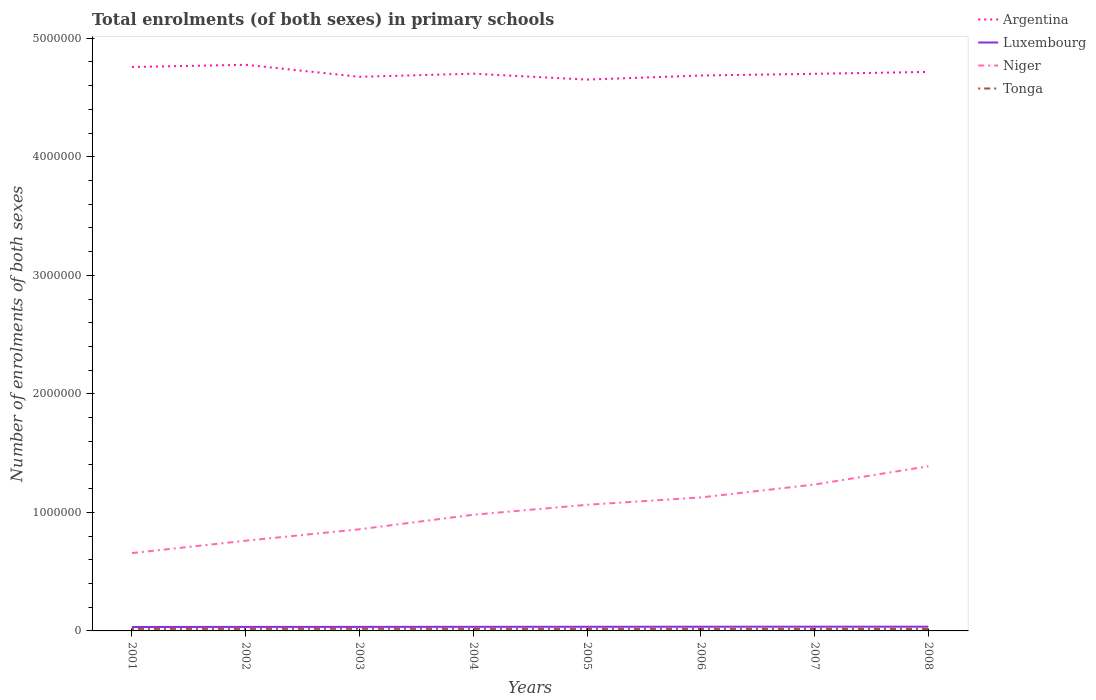How many different coloured lines are there?
Give a very brief answer. 4. Does the line corresponding to Luxembourg intersect with the line corresponding to Tonga?
Offer a terse response. No. Across all years, what is the maximum number of enrolments in primary schools in Argentina?
Your answer should be compact. 4.65e+06. What is the total number of enrolments in primary schools in Tonga in the graph?
Give a very brief answer. 49. What is the difference between the highest and the second highest number of enrolments in primary schools in Luxembourg?
Make the answer very short. 2402. What is the difference between the highest and the lowest number of enrolments in primary schools in Niger?
Ensure brevity in your answer.  4. How many lines are there?
Provide a succinct answer. 4. How many years are there in the graph?
Your answer should be compact. 8. What is the difference between two consecutive major ticks on the Y-axis?
Your answer should be very brief. 1.00e+06. Does the graph contain grids?
Provide a short and direct response. No. Where does the legend appear in the graph?
Provide a short and direct response. Top right. How are the legend labels stacked?
Ensure brevity in your answer.  Vertical. What is the title of the graph?
Offer a terse response. Total enrolments (of both sexes) in primary schools. What is the label or title of the Y-axis?
Provide a succinct answer. Number of enrolments of both sexes. What is the Number of enrolments of both sexes in Argentina in 2001?
Offer a terse response. 4.76e+06. What is the Number of enrolments of both sexes of Luxembourg in 2001?
Your answer should be compact. 3.33e+04. What is the Number of enrolments of both sexes in Niger in 2001?
Provide a short and direct response. 6.57e+05. What is the Number of enrolments of both sexes in Tonga in 2001?
Your answer should be very brief. 1.70e+04. What is the Number of enrolments of both sexes in Argentina in 2002?
Make the answer very short. 4.78e+06. What is the Number of enrolments of both sexes of Luxembourg in 2002?
Give a very brief answer. 3.40e+04. What is the Number of enrolments of both sexes in Niger in 2002?
Your answer should be very brief. 7.61e+05. What is the Number of enrolments of both sexes in Tonga in 2002?
Your answer should be compact. 1.71e+04. What is the Number of enrolments of both sexes in Argentina in 2003?
Your response must be concise. 4.67e+06. What is the Number of enrolments of both sexes of Luxembourg in 2003?
Your answer should be compact. 3.41e+04. What is the Number of enrolments of both sexes in Niger in 2003?
Provide a short and direct response. 8.58e+05. What is the Number of enrolments of both sexes of Tonga in 2003?
Your response must be concise. 1.79e+04. What is the Number of enrolments of both sexes of Argentina in 2004?
Provide a succinct answer. 4.70e+06. What is the Number of enrolments of both sexes in Luxembourg in 2004?
Keep it short and to the point. 3.46e+04. What is the Number of enrolments of both sexes of Niger in 2004?
Make the answer very short. 9.80e+05. What is the Number of enrolments of both sexes in Tonga in 2004?
Make the answer very short. 1.71e+04. What is the Number of enrolments of both sexes of Argentina in 2005?
Offer a terse response. 4.65e+06. What is the Number of enrolments of both sexes of Luxembourg in 2005?
Your answer should be compact. 3.50e+04. What is the Number of enrolments of both sexes of Niger in 2005?
Offer a terse response. 1.06e+06. What is the Number of enrolments of both sexes in Tonga in 2005?
Provide a short and direct response. 1.70e+04. What is the Number of enrolments of both sexes of Argentina in 2006?
Keep it short and to the point. 4.69e+06. What is the Number of enrolments of both sexes in Luxembourg in 2006?
Your answer should be very brief. 3.54e+04. What is the Number of enrolments of both sexes of Niger in 2006?
Offer a terse response. 1.13e+06. What is the Number of enrolments of both sexes in Tonga in 2006?
Your response must be concise. 1.69e+04. What is the Number of enrolments of both sexes of Argentina in 2007?
Offer a very short reply. 4.70e+06. What is the Number of enrolments of both sexes in Luxembourg in 2007?
Your answer should be compact. 3.57e+04. What is the Number of enrolments of both sexes of Niger in 2007?
Keep it short and to the point. 1.24e+06. What is the Number of enrolments of both sexes of Tonga in 2007?
Offer a very short reply. 1.69e+04. What is the Number of enrolments of both sexes in Argentina in 2008?
Make the answer very short. 4.72e+06. What is the Number of enrolments of both sexes in Luxembourg in 2008?
Your response must be concise. 3.56e+04. What is the Number of enrolments of both sexes in Niger in 2008?
Make the answer very short. 1.39e+06. What is the Number of enrolments of both sexes in Tonga in 2008?
Your answer should be very brief. 1.67e+04. Across all years, what is the maximum Number of enrolments of both sexes of Argentina?
Offer a very short reply. 4.78e+06. Across all years, what is the maximum Number of enrolments of both sexes in Luxembourg?
Ensure brevity in your answer.  3.57e+04. Across all years, what is the maximum Number of enrolments of both sexes in Niger?
Your answer should be very brief. 1.39e+06. Across all years, what is the maximum Number of enrolments of both sexes in Tonga?
Make the answer very short. 1.79e+04. Across all years, what is the minimum Number of enrolments of both sexes of Argentina?
Your response must be concise. 4.65e+06. Across all years, what is the minimum Number of enrolments of both sexes of Luxembourg?
Your answer should be compact. 3.33e+04. Across all years, what is the minimum Number of enrolments of both sexes in Niger?
Your answer should be compact. 6.57e+05. Across all years, what is the minimum Number of enrolments of both sexes of Tonga?
Provide a succinct answer. 1.67e+04. What is the total Number of enrolments of both sexes of Argentina in the graph?
Offer a very short reply. 3.77e+07. What is the total Number of enrolments of both sexes of Luxembourg in the graph?
Ensure brevity in your answer.  2.78e+05. What is the total Number of enrolments of both sexes in Niger in the graph?
Keep it short and to the point. 8.07e+06. What is the total Number of enrolments of both sexes in Tonga in the graph?
Your answer should be very brief. 1.37e+05. What is the difference between the Number of enrolments of both sexes in Argentina in 2001 and that in 2002?
Your answer should be compact. -1.86e+04. What is the difference between the Number of enrolments of both sexes in Luxembourg in 2001 and that in 2002?
Offer a terse response. -700. What is the difference between the Number of enrolments of both sexes of Niger in 2001 and that in 2002?
Provide a succinct answer. -1.04e+05. What is the difference between the Number of enrolments of both sexes of Tonga in 2001 and that in 2002?
Provide a succinct answer. -72. What is the difference between the Number of enrolments of both sexes of Argentina in 2001 and that in 2003?
Offer a very short reply. 8.28e+04. What is the difference between the Number of enrolments of both sexes of Luxembourg in 2001 and that in 2003?
Ensure brevity in your answer.  -815. What is the difference between the Number of enrolments of both sexes of Niger in 2001 and that in 2003?
Your answer should be very brief. -2.01e+05. What is the difference between the Number of enrolments of both sexes in Tonga in 2001 and that in 2003?
Provide a succinct answer. -858. What is the difference between the Number of enrolments of both sexes in Argentina in 2001 and that in 2004?
Ensure brevity in your answer.  5.65e+04. What is the difference between the Number of enrolments of both sexes of Luxembourg in 2001 and that in 2004?
Provide a short and direct response. -1337. What is the difference between the Number of enrolments of both sexes in Niger in 2001 and that in 2004?
Provide a succinct answer. -3.23e+05. What is the difference between the Number of enrolments of both sexes of Tonga in 2001 and that in 2004?
Make the answer very short. -80. What is the difference between the Number of enrolments of both sexes of Argentina in 2001 and that in 2005?
Provide a short and direct response. 1.06e+05. What is the difference between the Number of enrolments of both sexes of Luxembourg in 2001 and that in 2005?
Provide a succinct answer. -1750. What is the difference between the Number of enrolments of both sexes of Niger in 2001 and that in 2005?
Your answer should be very brief. -4.07e+05. What is the difference between the Number of enrolments of both sexes in Argentina in 2001 and that in 2006?
Keep it short and to the point. 7.20e+04. What is the difference between the Number of enrolments of both sexes of Luxembourg in 2001 and that in 2006?
Give a very brief answer. -2165. What is the difference between the Number of enrolments of both sexes in Niger in 2001 and that in 2006?
Your response must be concise. -4.69e+05. What is the difference between the Number of enrolments of both sexes of Tonga in 2001 and that in 2006?
Ensure brevity in your answer.  92. What is the difference between the Number of enrolments of both sexes in Argentina in 2001 and that in 2007?
Your answer should be compact. 5.75e+04. What is the difference between the Number of enrolments of both sexes in Luxembourg in 2001 and that in 2007?
Keep it short and to the point. -2402. What is the difference between the Number of enrolments of both sexes of Niger in 2001 and that in 2007?
Provide a succinct answer. -5.78e+05. What is the difference between the Number of enrolments of both sexes of Tonga in 2001 and that in 2007?
Ensure brevity in your answer.  141. What is the difference between the Number of enrolments of both sexes in Argentina in 2001 and that in 2008?
Provide a short and direct response. 4.16e+04. What is the difference between the Number of enrolments of both sexes in Luxembourg in 2001 and that in 2008?
Offer a terse response. -2364. What is the difference between the Number of enrolments of both sexes of Niger in 2001 and that in 2008?
Your response must be concise. -7.33e+05. What is the difference between the Number of enrolments of both sexes of Tonga in 2001 and that in 2008?
Offer a very short reply. 366. What is the difference between the Number of enrolments of both sexes in Argentina in 2002 and that in 2003?
Ensure brevity in your answer.  1.01e+05. What is the difference between the Number of enrolments of both sexes of Luxembourg in 2002 and that in 2003?
Provide a short and direct response. -115. What is the difference between the Number of enrolments of both sexes of Niger in 2002 and that in 2003?
Your answer should be compact. -9.66e+04. What is the difference between the Number of enrolments of both sexes of Tonga in 2002 and that in 2003?
Ensure brevity in your answer.  -786. What is the difference between the Number of enrolments of both sexes in Argentina in 2002 and that in 2004?
Keep it short and to the point. 7.52e+04. What is the difference between the Number of enrolments of both sexes of Luxembourg in 2002 and that in 2004?
Your answer should be very brief. -637. What is the difference between the Number of enrolments of both sexes in Niger in 2002 and that in 2004?
Make the answer very short. -2.19e+05. What is the difference between the Number of enrolments of both sexes of Tonga in 2002 and that in 2004?
Ensure brevity in your answer.  -8. What is the difference between the Number of enrolments of both sexes of Argentina in 2002 and that in 2005?
Your response must be concise. 1.25e+05. What is the difference between the Number of enrolments of both sexes of Luxembourg in 2002 and that in 2005?
Offer a very short reply. -1050. What is the difference between the Number of enrolments of both sexes in Niger in 2002 and that in 2005?
Provide a short and direct response. -3.03e+05. What is the difference between the Number of enrolments of both sexes in Argentina in 2002 and that in 2006?
Your answer should be compact. 9.06e+04. What is the difference between the Number of enrolments of both sexes in Luxembourg in 2002 and that in 2006?
Your answer should be very brief. -1465. What is the difference between the Number of enrolments of both sexes in Niger in 2002 and that in 2006?
Give a very brief answer. -3.65e+05. What is the difference between the Number of enrolments of both sexes of Tonga in 2002 and that in 2006?
Your answer should be compact. 164. What is the difference between the Number of enrolments of both sexes of Argentina in 2002 and that in 2007?
Provide a short and direct response. 7.61e+04. What is the difference between the Number of enrolments of both sexes in Luxembourg in 2002 and that in 2007?
Your response must be concise. -1702. What is the difference between the Number of enrolments of both sexes of Niger in 2002 and that in 2007?
Provide a short and direct response. -4.74e+05. What is the difference between the Number of enrolments of both sexes of Tonga in 2002 and that in 2007?
Ensure brevity in your answer.  213. What is the difference between the Number of enrolments of both sexes of Argentina in 2002 and that in 2008?
Your response must be concise. 6.02e+04. What is the difference between the Number of enrolments of both sexes of Luxembourg in 2002 and that in 2008?
Your response must be concise. -1664. What is the difference between the Number of enrolments of both sexes in Niger in 2002 and that in 2008?
Provide a succinct answer. -6.28e+05. What is the difference between the Number of enrolments of both sexes of Tonga in 2002 and that in 2008?
Provide a succinct answer. 438. What is the difference between the Number of enrolments of both sexes in Argentina in 2003 and that in 2004?
Make the answer very short. -2.63e+04. What is the difference between the Number of enrolments of both sexes of Luxembourg in 2003 and that in 2004?
Make the answer very short. -522. What is the difference between the Number of enrolments of both sexes of Niger in 2003 and that in 2004?
Your response must be concise. -1.22e+05. What is the difference between the Number of enrolments of both sexes in Tonga in 2003 and that in 2004?
Provide a short and direct response. 778. What is the difference between the Number of enrolments of both sexes in Argentina in 2003 and that in 2005?
Your response must be concise. 2.36e+04. What is the difference between the Number of enrolments of both sexes in Luxembourg in 2003 and that in 2005?
Offer a very short reply. -935. What is the difference between the Number of enrolments of both sexes of Niger in 2003 and that in 2005?
Your answer should be compact. -2.06e+05. What is the difference between the Number of enrolments of both sexes in Tonga in 2003 and that in 2005?
Your answer should be compact. 859. What is the difference between the Number of enrolments of both sexes of Argentina in 2003 and that in 2006?
Keep it short and to the point. -1.08e+04. What is the difference between the Number of enrolments of both sexes of Luxembourg in 2003 and that in 2006?
Offer a terse response. -1350. What is the difference between the Number of enrolments of both sexes in Niger in 2003 and that in 2006?
Offer a terse response. -2.68e+05. What is the difference between the Number of enrolments of both sexes of Tonga in 2003 and that in 2006?
Offer a terse response. 950. What is the difference between the Number of enrolments of both sexes of Argentina in 2003 and that in 2007?
Offer a very short reply. -2.53e+04. What is the difference between the Number of enrolments of both sexes of Luxembourg in 2003 and that in 2007?
Make the answer very short. -1587. What is the difference between the Number of enrolments of both sexes of Niger in 2003 and that in 2007?
Your answer should be compact. -3.77e+05. What is the difference between the Number of enrolments of both sexes in Tonga in 2003 and that in 2007?
Offer a terse response. 999. What is the difference between the Number of enrolments of both sexes of Argentina in 2003 and that in 2008?
Your response must be concise. -4.12e+04. What is the difference between the Number of enrolments of both sexes in Luxembourg in 2003 and that in 2008?
Offer a very short reply. -1549. What is the difference between the Number of enrolments of both sexes of Niger in 2003 and that in 2008?
Provide a succinct answer. -5.32e+05. What is the difference between the Number of enrolments of both sexes of Tonga in 2003 and that in 2008?
Your response must be concise. 1224. What is the difference between the Number of enrolments of both sexes in Argentina in 2004 and that in 2005?
Give a very brief answer. 4.99e+04. What is the difference between the Number of enrolments of both sexes of Luxembourg in 2004 and that in 2005?
Ensure brevity in your answer.  -413. What is the difference between the Number of enrolments of both sexes in Niger in 2004 and that in 2005?
Give a very brief answer. -8.40e+04. What is the difference between the Number of enrolments of both sexes of Tonga in 2004 and that in 2005?
Offer a very short reply. 81. What is the difference between the Number of enrolments of both sexes of Argentina in 2004 and that in 2006?
Make the answer very short. 1.55e+04. What is the difference between the Number of enrolments of both sexes in Luxembourg in 2004 and that in 2006?
Offer a terse response. -828. What is the difference between the Number of enrolments of both sexes of Niger in 2004 and that in 2006?
Provide a succinct answer. -1.46e+05. What is the difference between the Number of enrolments of both sexes in Tonga in 2004 and that in 2006?
Make the answer very short. 172. What is the difference between the Number of enrolments of both sexes in Argentina in 2004 and that in 2007?
Ensure brevity in your answer.  973. What is the difference between the Number of enrolments of both sexes in Luxembourg in 2004 and that in 2007?
Provide a succinct answer. -1065. What is the difference between the Number of enrolments of both sexes of Niger in 2004 and that in 2007?
Ensure brevity in your answer.  -2.55e+05. What is the difference between the Number of enrolments of both sexes of Tonga in 2004 and that in 2007?
Provide a succinct answer. 221. What is the difference between the Number of enrolments of both sexes in Argentina in 2004 and that in 2008?
Your answer should be very brief. -1.50e+04. What is the difference between the Number of enrolments of both sexes of Luxembourg in 2004 and that in 2008?
Give a very brief answer. -1027. What is the difference between the Number of enrolments of both sexes in Niger in 2004 and that in 2008?
Your answer should be compact. -4.09e+05. What is the difference between the Number of enrolments of both sexes of Tonga in 2004 and that in 2008?
Make the answer very short. 446. What is the difference between the Number of enrolments of both sexes of Argentina in 2005 and that in 2006?
Ensure brevity in your answer.  -3.44e+04. What is the difference between the Number of enrolments of both sexes in Luxembourg in 2005 and that in 2006?
Make the answer very short. -415. What is the difference between the Number of enrolments of both sexes in Niger in 2005 and that in 2006?
Provide a short and direct response. -6.20e+04. What is the difference between the Number of enrolments of both sexes of Tonga in 2005 and that in 2006?
Provide a succinct answer. 91. What is the difference between the Number of enrolments of both sexes of Argentina in 2005 and that in 2007?
Offer a terse response. -4.89e+04. What is the difference between the Number of enrolments of both sexes in Luxembourg in 2005 and that in 2007?
Your response must be concise. -652. What is the difference between the Number of enrolments of both sexes of Niger in 2005 and that in 2007?
Ensure brevity in your answer.  -1.71e+05. What is the difference between the Number of enrolments of both sexes in Tonga in 2005 and that in 2007?
Your response must be concise. 140. What is the difference between the Number of enrolments of both sexes in Argentina in 2005 and that in 2008?
Give a very brief answer. -6.48e+04. What is the difference between the Number of enrolments of both sexes in Luxembourg in 2005 and that in 2008?
Offer a terse response. -614. What is the difference between the Number of enrolments of both sexes in Niger in 2005 and that in 2008?
Offer a very short reply. -3.25e+05. What is the difference between the Number of enrolments of both sexes in Tonga in 2005 and that in 2008?
Make the answer very short. 365. What is the difference between the Number of enrolments of both sexes in Argentina in 2006 and that in 2007?
Your answer should be very brief. -1.45e+04. What is the difference between the Number of enrolments of both sexes of Luxembourg in 2006 and that in 2007?
Make the answer very short. -237. What is the difference between the Number of enrolments of both sexes of Niger in 2006 and that in 2007?
Ensure brevity in your answer.  -1.09e+05. What is the difference between the Number of enrolments of both sexes in Argentina in 2006 and that in 2008?
Give a very brief answer. -3.04e+04. What is the difference between the Number of enrolments of both sexes in Luxembourg in 2006 and that in 2008?
Your answer should be very brief. -199. What is the difference between the Number of enrolments of both sexes of Niger in 2006 and that in 2008?
Keep it short and to the point. -2.63e+05. What is the difference between the Number of enrolments of both sexes in Tonga in 2006 and that in 2008?
Provide a short and direct response. 274. What is the difference between the Number of enrolments of both sexes of Argentina in 2007 and that in 2008?
Provide a succinct answer. -1.59e+04. What is the difference between the Number of enrolments of both sexes of Niger in 2007 and that in 2008?
Ensure brevity in your answer.  -1.54e+05. What is the difference between the Number of enrolments of both sexes in Tonga in 2007 and that in 2008?
Keep it short and to the point. 225. What is the difference between the Number of enrolments of both sexes of Argentina in 2001 and the Number of enrolments of both sexes of Luxembourg in 2002?
Ensure brevity in your answer.  4.72e+06. What is the difference between the Number of enrolments of both sexes in Argentina in 2001 and the Number of enrolments of both sexes in Niger in 2002?
Offer a very short reply. 4.00e+06. What is the difference between the Number of enrolments of both sexes in Argentina in 2001 and the Number of enrolments of both sexes in Tonga in 2002?
Provide a short and direct response. 4.74e+06. What is the difference between the Number of enrolments of both sexes of Luxembourg in 2001 and the Number of enrolments of both sexes of Niger in 2002?
Provide a short and direct response. -7.28e+05. What is the difference between the Number of enrolments of both sexes in Luxembourg in 2001 and the Number of enrolments of both sexes in Tonga in 2002?
Provide a short and direct response. 1.62e+04. What is the difference between the Number of enrolments of both sexes of Niger in 2001 and the Number of enrolments of both sexes of Tonga in 2002?
Ensure brevity in your answer.  6.39e+05. What is the difference between the Number of enrolments of both sexes of Argentina in 2001 and the Number of enrolments of both sexes of Luxembourg in 2003?
Ensure brevity in your answer.  4.72e+06. What is the difference between the Number of enrolments of both sexes of Argentina in 2001 and the Number of enrolments of both sexes of Niger in 2003?
Provide a short and direct response. 3.90e+06. What is the difference between the Number of enrolments of both sexes of Argentina in 2001 and the Number of enrolments of both sexes of Tonga in 2003?
Keep it short and to the point. 4.74e+06. What is the difference between the Number of enrolments of both sexes in Luxembourg in 2001 and the Number of enrolments of both sexes in Niger in 2003?
Make the answer very short. -8.24e+05. What is the difference between the Number of enrolments of both sexes in Luxembourg in 2001 and the Number of enrolments of both sexes in Tonga in 2003?
Ensure brevity in your answer.  1.54e+04. What is the difference between the Number of enrolments of both sexes of Niger in 2001 and the Number of enrolments of both sexes of Tonga in 2003?
Provide a short and direct response. 6.39e+05. What is the difference between the Number of enrolments of both sexes in Argentina in 2001 and the Number of enrolments of both sexes in Luxembourg in 2004?
Ensure brevity in your answer.  4.72e+06. What is the difference between the Number of enrolments of both sexes of Argentina in 2001 and the Number of enrolments of both sexes of Niger in 2004?
Keep it short and to the point. 3.78e+06. What is the difference between the Number of enrolments of both sexes of Argentina in 2001 and the Number of enrolments of both sexes of Tonga in 2004?
Your answer should be very brief. 4.74e+06. What is the difference between the Number of enrolments of both sexes in Luxembourg in 2001 and the Number of enrolments of both sexes in Niger in 2004?
Your answer should be compact. -9.47e+05. What is the difference between the Number of enrolments of both sexes in Luxembourg in 2001 and the Number of enrolments of both sexes in Tonga in 2004?
Give a very brief answer. 1.62e+04. What is the difference between the Number of enrolments of both sexes in Niger in 2001 and the Number of enrolments of both sexes in Tonga in 2004?
Offer a terse response. 6.39e+05. What is the difference between the Number of enrolments of both sexes of Argentina in 2001 and the Number of enrolments of both sexes of Luxembourg in 2005?
Keep it short and to the point. 4.72e+06. What is the difference between the Number of enrolments of both sexes in Argentina in 2001 and the Number of enrolments of both sexes in Niger in 2005?
Keep it short and to the point. 3.69e+06. What is the difference between the Number of enrolments of both sexes of Argentina in 2001 and the Number of enrolments of both sexes of Tonga in 2005?
Offer a terse response. 4.74e+06. What is the difference between the Number of enrolments of both sexes in Luxembourg in 2001 and the Number of enrolments of both sexes in Niger in 2005?
Give a very brief answer. -1.03e+06. What is the difference between the Number of enrolments of both sexes of Luxembourg in 2001 and the Number of enrolments of both sexes of Tonga in 2005?
Make the answer very short. 1.62e+04. What is the difference between the Number of enrolments of both sexes in Niger in 2001 and the Number of enrolments of both sexes in Tonga in 2005?
Offer a terse response. 6.40e+05. What is the difference between the Number of enrolments of both sexes in Argentina in 2001 and the Number of enrolments of both sexes in Luxembourg in 2006?
Provide a succinct answer. 4.72e+06. What is the difference between the Number of enrolments of both sexes in Argentina in 2001 and the Number of enrolments of both sexes in Niger in 2006?
Make the answer very short. 3.63e+06. What is the difference between the Number of enrolments of both sexes in Argentina in 2001 and the Number of enrolments of both sexes in Tonga in 2006?
Offer a terse response. 4.74e+06. What is the difference between the Number of enrolments of both sexes of Luxembourg in 2001 and the Number of enrolments of both sexes of Niger in 2006?
Your answer should be very brief. -1.09e+06. What is the difference between the Number of enrolments of both sexes in Luxembourg in 2001 and the Number of enrolments of both sexes in Tonga in 2006?
Your answer should be very brief. 1.63e+04. What is the difference between the Number of enrolments of both sexes in Niger in 2001 and the Number of enrolments of both sexes in Tonga in 2006?
Give a very brief answer. 6.40e+05. What is the difference between the Number of enrolments of both sexes in Argentina in 2001 and the Number of enrolments of both sexes in Luxembourg in 2007?
Make the answer very short. 4.72e+06. What is the difference between the Number of enrolments of both sexes of Argentina in 2001 and the Number of enrolments of both sexes of Niger in 2007?
Ensure brevity in your answer.  3.52e+06. What is the difference between the Number of enrolments of both sexes of Argentina in 2001 and the Number of enrolments of both sexes of Tonga in 2007?
Make the answer very short. 4.74e+06. What is the difference between the Number of enrolments of both sexes of Luxembourg in 2001 and the Number of enrolments of both sexes of Niger in 2007?
Provide a short and direct response. -1.20e+06. What is the difference between the Number of enrolments of both sexes in Luxembourg in 2001 and the Number of enrolments of both sexes in Tonga in 2007?
Your answer should be compact. 1.64e+04. What is the difference between the Number of enrolments of both sexes in Niger in 2001 and the Number of enrolments of both sexes in Tonga in 2007?
Your answer should be compact. 6.40e+05. What is the difference between the Number of enrolments of both sexes in Argentina in 2001 and the Number of enrolments of both sexes in Luxembourg in 2008?
Offer a terse response. 4.72e+06. What is the difference between the Number of enrolments of both sexes of Argentina in 2001 and the Number of enrolments of both sexes of Niger in 2008?
Your answer should be compact. 3.37e+06. What is the difference between the Number of enrolments of both sexes of Argentina in 2001 and the Number of enrolments of both sexes of Tonga in 2008?
Keep it short and to the point. 4.74e+06. What is the difference between the Number of enrolments of both sexes in Luxembourg in 2001 and the Number of enrolments of both sexes in Niger in 2008?
Your answer should be very brief. -1.36e+06. What is the difference between the Number of enrolments of both sexes in Luxembourg in 2001 and the Number of enrolments of both sexes in Tonga in 2008?
Offer a terse response. 1.66e+04. What is the difference between the Number of enrolments of both sexes in Niger in 2001 and the Number of enrolments of both sexes in Tonga in 2008?
Your answer should be very brief. 6.40e+05. What is the difference between the Number of enrolments of both sexes in Argentina in 2002 and the Number of enrolments of both sexes in Luxembourg in 2003?
Your response must be concise. 4.74e+06. What is the difference between the Number of enrolments of both sexes of Argentina in 2002 and the Number of enrolments of both sexes of Niger in 2003?
Your answer should be very brief. 3.92e+06. What is the difference between the Number of enrolments of both sexes of Argentina in 2002 and the Number of enrolments of both sexes of Tonga in 2003?
Offer a terse response. 4.76e+06. What is the difference between the Number of enrolments of both sexes in Luxembourg in 2002 and the Number of enrolments of both sexes in Niger in 2003?
Your answer should be compact. -8.24e+05. What is the difference between the Number of enrolments of both sexes of Luxembourg in 2002 and the Number of enrolments of both sexes of Tonga in 2003?
Keep it short and to the point. 1.61e+04. What is the difference between the Number of enrolments of both sexes in Niger in 2002 and the Number of enrolments of both sexes in Tonga in 2003?
Your answer should be very brief. 7.43e+05. What is the difference between the Number of enrolments of both sexes of Argentina in 2002 and the Number of enrolments of both sexes of Luxembourg in 2004?
Offer a very short reply. 4.74e+06. What is the difference between the Number of enrolments of both sexes in Argentina in 2002 and the Number of enrolments of both sexes in Niger in 2004?
Provide a short and direct response. 3.80e+06. What is the difference between the Number of enrolments of both sexes in Argentina in 2002 and the Number of enrolments of both sexes in Tonga in 2004?
Keep it short and to the point. 4.76e+06. What is the difference between the Number of enrolments of both sexes in Luxembourg in 2002 and the Number of enrolments of both sexes in Niger in 2004?
Provide a succinct answer. -9.46e+05. What is the difference between the Number of enrolments of both sexes in Luxembourg in 2002 and the Number of enrolments of both sexes in Tonga in 2004?
Ensure brevity in your answer.  1.69e+04. What is the difference between the Number of enrolments of both sexes of Niger in 2002 and the Number of enrolments of both sexes of Tonga in 2004?
Keep it short and to the point. 7.44e+05. What is the difference between the Number of enrolments of both sexes of Argentina in 2002 and the Number of enrolments of both sexes of Luxembourg in 2005?
Give a very brief answer. 4.74e+06. What is the difference between the Number of enrolments of both sexes of Argentina in 2002 and the Number of enrolments of both sexes of Niger in 2005?
Give a very brief answer. 3.71e+06. What is the difference between the Number of enrolments of both sexes in Argentina in 2002 and the Number of enrolments of both sexes in Tonga in 2005?
Offer a terse response. 4.76e+06. What is the difference between the Number of enrolments of both sexes in Luxembourg in 2002 and the Number of enrolments of both sexes in Niger in 2005?
Offer a terse response. -1.03e+06. What is the difference between the Number of enrolments of both sexes of Luxembourg in 2002 and the Number of enrolments of both sexes of Tonga in 2005?
Your answer should be very brief. 1.69e+04. What is the difference between the Number of enrolments of both sexes in Niger in 2002 and the Number of enrolments of both sexes in Tonga in 2005?
Keep it short and to the point. 7.44e+05. What is the difference between the Number of enrolments of both sexes of Argentina in 2002 and the Number of enrolments of both sexes of Luxembourg in 2006?
Keep it short and to the point. 4.74e+06. What is the difference between the Number of enrolments of both sexes in Argentina in 2002 and the Number of enrolments of both sexes in Niger in 2006?
Offer a very short reply. 3.65e+06. What is the difference between the Number of enrolments of both sexes of Argentina in 2002 and the Number of enrolments of both sexes of Tonga in 2006?
Your answer should be very brief. 4.76e+06. What is the difference between the Number of enrolments of both sexes in Luxembourg in 2002 and the Number of enrolments of both sexes in Niger in 2006?
Give a very brief answer. -1.09e+06. What is the difference between the Number of enrolments of both sexes of Luxembourg in 2002 and the Number of enrolments of both sexes of Tonga in 2006?
Your response must be concise. 1.70e+04. What is the difference between the Number of enrolments of both sexes in Niger in 2002 and the Number of enrolments of both sexes in Tonga in 2006?
Make the answer very short. 7.44e+05. What is the difference between the Number of enrolments of both sexes of Argentina in 2002 and the Number of enrolments of both sexes of Luxembourg in 2007?
Make the answer very short. 4.74e+06. What is the difference between the Number of enrolments of both sexes of Argentina in 2002 and the Number of enrolments of both sexes of Niger in 2007?
Provide a short and direct response. 3.54e+06. What is the difference between the Number of enrolments of both sexes in Argentina in 2002 and the Number of enrolments of both sexes in Tonga in 2007?
Provide a short and direct response. 4.76e+06. What is the difference between the Number of enrolments of both sexes of Luxembourg in 2002 and the Number of enrolments of both sexes of Niger in 2007?
Your response must be concise. -1.20e+06. What is the difference between the Number of enrolments of both sexes of Luxembourg in 2002 and the Number of enrolments of both sexes of Tonga in 2007?
Give a very brief answer. 1.71e+04. What is the difference between the Number of enrolments of both sexes in Niger in 2002 and the Number of enrolments of both sexes in Tonga in 2007?
Ensure brevity in your answer.  7.44e+05. What is the difference between the Number of enrolments of both sexes of Argentina in 2002 and the Number of enrolments of both sexes of Luxembourg in 2008?
Your answer should be very brief. 4.74e+06. What is the difference between the Number of enrolments of both sexes in Argentina in 2002 and the Number of enrolments of both sexes in Niger in 2008?
Your answer should be compact. 3.39e+06. What is the difference between the Number of enrolments of both sexes of Argentina in 2002 and the Number of enrolments of both sexes of Tonga in 2008?
Provide a short and direct response. 4.76e+06. What is the difference between the Number of enrolments of both sexes of Luxembourg in 2002 and the Number of enrolments of both sexes of Niger in 2008?
Your answer should be very brief. -1.36e+06. What is the difference between the Number of enrolments of both sexes in Luxembourg in 2002 and the Number of enrolments of both sexes in Tonga in 2008?
Your answer should be very brief. 1.73e+04. What is the difference between the Number of enrolments of both sexes in Niger in 2002 and the Number of enrolments of both sexes in Tonga in 2008?
Offer a terse response. 7.44e+05. What is the difference between the Number of enrolments of both sexes of Argentina in 2003 and the Number of enrolments of both sexes of Luxembourg in 2004?
Provide a short and direct response. 4.64e+06. What is the difference between the Number of enrolments of both sexes of Argentina in 2003 and the Number of enrolments of both sexes of Niger in 2004?
Keep it short and to the point. 3.69e+06. What is the difference between the Number of enrolments of both sexes in Argentina in 2003 and the Number of enrolments of both sexes in Tonga in 2004?
Your answer should be very brief. 4.66e+06. What is the difference between the Number of enrolments of both sexes in Luxembourg in 2003 and the Number of enrolments of both sexes in Niger in 2004?
Make the answer very short. -9.46e+05. What is the difference between the Number of enrolments of both sexes in Luxembourg in 2003 and the Number of enrolments of both sexes in Tonga in 2004?
Keep it short and to the point. 1.70e+04. What is the difference between the Number of enrolments of both sexes in Niger in 2003 and the Number of enrolments of both sexes in Tonga in 2004?
Your answer should be compact. 8.40e+05. What is the difference between the Number of enrolments of both sexes in Argentina in 2003 and the Number of enrolments of both sexes in Luxembourg in 2005?
Keep it short and to the point. 4.64e+06. What is the difference between the Number of enrolments of both sexes of Argentina in 2003 and the Number of enrolments of both sexes of Niger in 2005?
Your answer should be compact. 3.61e+06. What is the difference between the Number of enrolments of both sexes of Argentina in 2003 and the Number of enrolments of both sexes of Tonga in 2005?
Ensure brevity in your answer.  4.66e+06. What is the difference between the Number of enrolments of both sexes in Luxembourg in 2003 and the Number of enrolments of both sexes in Niger in 2005?
Make the answer very short. -1.03e+06. What is the difference between the Number of enrolments of both sexes in Luxembourg in 2003 and the Number of enrolments of both sexes in Tonga in 2005?
Offer a very short reply. 1.70e+04. What is the difference between the Number of enrolments of both sexes in Niger in 2003 and the Number of enrolments of both sexes in Tonga in 2005?
Give a very brief answer. 8.41e+05. What is the difference between the Number of enrolments of both sexes of Argentina in 2003 and the Number of enrolments of both sexes of Luxembourg in 2006?
Offer a terse response. 4.64e+06. What is the difference between the Number of enrolments of both sexes of Argentina in 2003 and the Number of enrolments of both sexes of Niger in 2006?
Provide a succinct answer. 3.55e+06. What is the difference between the Number of enrolments of both sexes in Argentina in 2003 and the Number of enrolments of both sexes in Tonga in 2006?
Provide a succinct answer. 4.66e+06. What is the difference between the Number of enrolments of both sexes of Luxembourg in 2003 and the Number of enrolments of both sexes of Niger in 2006?
Provide a short and direct response. -1.09e+06. What is the difference between the Number of enrolments of both sexes of Luxembourg in 2003 and the Number of enrolments of both sexes of Tonga in 2006?
Make the answer very short. 1.71e+04. What is the difference between the Number of enrolments of both sexes of Niger in 2003 and the Number of enrolments of both sexes of Tonga in 2006?
Ensure brevity in your answer.  8.41e+05. What is the difference between the Number of enrolments of both sexes of Argentina in 2003 and the Number of enrolments of both sexes of Luxembourg in 2007?
Your answer should be compact. 4.64e+06. What is the difference between the Number of enrolments of both sexes of Argentina in 2003 and the Number of enrolments of both sexes of Niger in 2007?
Provide a succinct answer. 3.44e+06. What is the difference between the Number of enrolments of both sexes in Argentina in 2003 and the Number of enrolments of both sexes in Tonga in 2007?
Ensure brevity in your answer.  4.66e+06. What is the difference between the Number of enrolments of both sexes of Luxembourg in 2003 and the Number of enrolments of both sexes of Niger in 2007?
Make the answer very short. -1.20e+06. What is the difference between the Number of enrolments of both sexes of Luxembourg in 2003 and the Number of enrolments of both sexes of Tonga in 2007?
Ensure brevity in your answer.  1.72e+04. What is the difference between the Number of enrolments of both sexes in Niger in 2003 and the Number of enrolments of both sexes in Tonga in 2007?
Offer a very short reply. 8.41e+05. What is the difference between the Number of enrolments of both sexes in Argentina in 2003 and the Number of enrolments of both sexes in Luxembourg in 2008?
Make the answer very short. 4.64e+06. What is the difference between the Number of enrolments of both sexes in Argentina in 2003 and the Number of enrolments of both sexes in Niger in 2008?
Provide a succinct answer. 3.29e+06. What is the difference between the Number of enrolments of both sexes in Argentina in 2003 and the Number of enrolments of both sexes in Tonga in 2008?
Make the answer very short. 4.66e+06. What is the difference between the Number of enrolments of both sexes in Luxembourg in 2003 and the Number of enrolments of both sexes in Niger in 2008?
Provide a succinct answer. -1.36e+06. What is the difference between the Number of enrolments of both sexes of Luxembourg in 2003 and the Number of enrolments of both sexes of Tonga in 2008?
Provide a short and direct response. 1.74e+04. What is the difference between the Number of enrolments of both sexes of Niger in 2003 and the Number of enrolments of both sexes of Tonga in 2008?
Give a very brief answer. 8.41e+05. What is the difference between the Number of enrolments of both sexes of Argentina in 2004 and the Number of enrolments of both sexes of Luxembourg in 2005?
Your answer should be very brief. 4.67e+06. What is the difference between the Number of enrolments of both sexes in Argentina in 2004 and the Number of enrolments of both sexes in Niger in 2005?
Give a very brief answer. 3.64e+06. What is the difference between the Number of enrolments of both sexes in Argentina in 2004 and the Number of enrolments of both sexes in Tonga in 2005?
Make the answer very short. 4.68e+06. What is the difference between the Number of enrolments of both sexes of Luxembourg in 2004 and the Number of enrolments of both sexes of Niger in 2005?
Give a very brief answer. -1.03e+06. What is the difference between the Number of enrolments of both sexes of Luxembourg in 2004 and the Number of enrolments of both sexes of Tonga in 2005?
Offer a terse response. 1.76e+04. What is the difference between the Number of enrolments of both sexes of Niger in 2004 and the Number of enrolments of both sexes of Tonga in 2005?
Offer a terse response. 9.63e+05. What is the difference between the Number of enrolments of both sexes in Argentina in 2004 and the Number of enrolments of both sexes in Luxembourg in 2006?
Your answer should be compact. 4.67e+06. What is the difference between the Number of enrolments of both sexes in Argentina in 2004 and the Number of enrolments of both sexes in Niger in 2006?
Your response must be concise. 3.58e+06. What is the difference between the Number of enrolments of both sexes in Argentina in 2004 and the Number of enrolments of both sexes in Tonga in 2006?
Make the answer very short. 4.68e+06. What is the difference between the Number of enrolments of both sexes in Luxembourg in 2004 and the Number of enrolments of both sexes in Niger in 2006?
Offer a very short reply. -1.09e+06. What is the difference between the Number of enrolments of both sexes in Luxembourg in 2004 and the Number of enrolments of both sexes in Tonga in 2006?
Offer a very short reply. 1.77e+04. What is the difference between the Number of enrolments of both sexes of Niger in 2004 and the Number of enrolments of both sexes of Tonga in 2006?
Your answer should be compact. 9.63e+05. What is the difference between the Number of enrolments of both sexes in Argentina in 2004 and the Number of enrolments of both sexes in Luxembourg in 2007?
Offer a very short reply. 4.67e+06. What is the difference between the Number of enrolments of both sexes of Argentina in 2004 and the Number of enrolments of both sexes of Niger in 2007?
Give a very brief answer. 3.47e+06. What is the difference between the Number of enrolments of both sexes in Argentina in 2004 and the Number of enrolments of both sexes in Tonga in 2007?
Make the answer very short. 4.68e+06. What is the difference between the Number of enrolments of both sexes in Luxembourg in 2004 and the Number of enrolments of both sexes in Niger in 2007?
Your response must be concise. -1.20e+06. What is the difference between the Number of enrolments of both sexes of Luxembourg in 2004 and the Number of enrolments of both sexes of Tonga in 2007?
Provide a succinct answer. 1.77e+04. What is the difference between the Number of enrolments of both sexes of Niger in 2004 and the Number of enrolments of both sexes of Tonga in 2007?
Your answer should be very brief. 9.63e+05. What is the difference between the Number of enrolments of both sexes of Argentina in 2004 and the Number of enrolments of both sexes of Luxembourg in 2008?
Keep it short and to the point. 4.67e+06. What is the difference between the Number of enrolments of both sexes of Argentina in 2004 and the Number of enrolments of both sexes of Niger in 2008?
Ensure brevity in your answer.  3.31e+06. What is the difference between the Number of enrolments of both sexes of Argentina in 2004 and the Number of enrolments of both sexes of Tonga in 2008?
Offer a terse response. 4.68e+06. What is the difference between the Number of enrolments of both sexes of Luxembourg in 2004 and the Number of enrolments of both sexes of Niger in 2008?
Your answer should be compact. -1.35e+06. What is the difference between the Number of enrolments of both sexes of Luxembourg in 2004 and the Number of enrolments of both sexes of Tonga in 2008?
Offer a very short reply. 1.79e+04. What is the difference between the Number of enrolments of both sexes of Niger in 2004 and the Number of enrolments of both sexes of Tonga in 2008?
Give a very brief answer. 9.63e+05. What is the difference between the Number of enrolments of both sexes in Argentina in 2005 and the Number of enrolments of both sexes in Luxembourg in 2006?
Offer a very short reply. 4.62e+06. What is the difference between the Number of enrolments of both sexes in Argentina in 2005 and the Number of enrolments of both sexes in Niger in 2006?
Give a very brief answer. 3.53e+06. What is the difference between the Number of enrolments of both sexes of Argentina in 2005 and the Number of enrolments of both sexes of Tonga in 2006?
Your response must be concise. 4.63e+06. What is the difference between the Number of enrolments of both sexes in Luxembourg in 2005 and the Number of enrolments of both sexes in Niger in 2006?
Your response must be concise. -1.09e+06. What is the difference between the Number of enrolments of both sexes in Luxembourg in 2005 and the Number of enrolments of both sexes in Tonga in 2006?
Keep it short and to the point. 1.81e+04. What is the difference between the Number of enrolments of both sexes of Niger in 2005 and the Number of enrolments of both sexes of Tonga in 2006?
Offer a very short reply. 1.05e+06. What is the difference between the Number of enrolments of both sexes of Argentina in 2005 and the Number of enrolments of both sexes of Luxembourg in 2007?
Provide a succinct answer. 4.62e+06. What is the difference between the Number of enrolments of both sexes of Argentina in 2005 and the Number of enrolments of both sexes of Niger in 2007?
Ensure brevity in your answer.  3.42e+06. What is the difference between the Number of enrolments of both sexes in Argentina in 2005 and the Number of enrolments of both sexes in Tonga in 2007?
Your answer should be very brief. 4.63e+06. What is the difference between the Number of enrolments of both sexes in Luxembourg in 2005 and the Number of enrolments of both sexes in Niger in 2007?
Offer a terse response. -1.20e+06. What is the difference between the Number of enrolments of both sexes in Luxembourg in 2005 and the Number of enrolments of both sexes in Tonga in 2007?
Keep it short and to the point. 1.81e+04. What is the difference between the Number of enrolments of both sexes of Niger in 2005 and the Number of enrolments of both sexes of Tonga in 2007?
Your response must be concise. 1.05e+06. What is the difference between the Number of enrolments of both sexes of Argentina in 2005 and the Number of enrolments of both sexes of Luxembourg in 2008?
Your answer should be very brief. 4.62e+06. What is the difference between the Number of enrolments of both sexes in Argentina in 2005 and the Number of enrolments of both sexes in Niger in 2008?
Offer a terse response. 3.26e+06. What is the difference between the Number of enrolments of both sexes in Argentina in 2005 and the Number of enrolments of both sexes in Tonga in 2008?
Your answer should be compact. 4.63e+06. What is the difference between the Number of enrolments of both sexes in Luxembourg in 2005 and the Number of enrolments of both sexes in Niger in 2008?
Keep it short and to the point. -1.35e+06. What is the difference between the Number of enrolments of both sexes in Luxembourg in 2005 and the Number of enrolments of both sexes in Tonga in 2008?
Your response must be concise. 1.83e+04. What is the difference between the Number of enrolments of both sexes in Niger in 2005 and the Number of enrolments of both sexes in Tonga in 2008?
Your answer should be very brief. 1.05e+06. What is the difference between the Number of enrolments of both sexes of Argentina in 2006 and the Number of enrolments of both sexes of Luxembourg in 2007?
Offer a terse response. 4.65e+06. What is the difference between the Number of enrolments of both sexes in Argentina in 2006 and the Number of enrolments of both sexes in Niger in 2007?
Offer a terse response. 3.45e+06. What is the difference between the Number of enrolments of both sexes in Argentina in 2006 and the Number of enrolments of both sexes in Tonga in 2007?
Your answer should be compact. 4.67e+06. What is the difference between the Number of enrolments of both sexes in Luxembourg in 2006 and the Number of enrolments of both sexes in Niger in 2007?
Your response must be concise. -1.20e+06. What is the difference between the Number of enrolments of both sexes in Luxembourg in 2006 and the Number of enrolments of both sexes in Tonga in 2007?
Give a very brief answer. 1.85e+04. What is the difference between the Number of enrolments of both sexes of Niger in 2006 and the Number of enrolments of both sexes of Tonga in 2007?
Offer a very short reply. 1.11e+06. What is the difference between the Number of enrolments of both sexes in Argentina in 2006 and the Number of enrolments of both sexes in Luxembourg in 2008?
Your answer should be very brief. 4.65e+06. What is the difference between the Number of enrolments of both sexes of Argentina in 2006 and the Number of enrolments of both sexes of Niger in 2008?
Provide a short and direct response. 3.30e+06. What is the difference between the Number of enrolments of both sexes in Argentina in 2006 and the Number of enrolments of both sexes in Tonga in 2008?
Keep it short and to the point. 4.67e+06. What is the difference between the Number of enrolments of both sexes in Luxembourg in 2006 and the Number of enrolments of both sexes in Niger in 2008?
Your response must be concise. -1.35e+06. What is the difference between the Number of enrolments of both sexes in Luxembourg in 2006 and the Number of enrolments of both sexes in Tonga in 2008?
Your answer should be very brief. 1.88e+04. What is the difference between the Number of enrolments of both sexes of Niger in 2006 and the Number of enrolments of both sexes of Tonga in 2008?
Provide a succinct answer. 1.11e+06. What is the difference between the Number of enrolments of both sexes in Argentina in 2007 and the Number of enrolments of both sexes in Luxembourg in 2008?
Keep it short and to the point. 4.66e+06. What is the difference between the Number of enrolments of both sexes of Argentina in 2007 and the Number of enrolments of both sexes of Niger in 2008?
Your answer should be compact. 3.31e+06. What is the difference between the Number of enrolments of both sexes of Argentina in 2007 and the Number of enrolments of both sexes of Tonga in 2008?
Ensure brevity in your answer.  4.68e+06. What is the difference between the Number of enrolments of both sexes of Luxembourg in 2007 and the Number of enrolments of both sexes of Niger in 2008?
Offer a terse response. -1.35e+06. What is the difference between the Number of enrolments of both sexes of Luxembourg in 2007 and the Number of enrolments of both sexes of Tonga in 2008?
Give a very brief answer. 1.90e+04. What is the difference between the Number of enrolments of both sexes in Niger in 2007 and the Number of enrolments of both sexes in Tonga in 2008?
Make the answer very short. 1.22e+06. What is the average Number of enrolments of both sexes in Argentina per year?
Give a very brief answer. 4.71e+06. What is the average Number of enrolments of both sexes in Luxembourg per year?
Offer a terse response. 3.47e+04. What is the average Number of enrolments of both sexes of Niger per year?
Make the answer very short. 1.01e+06. What is the average Number of enrolments of both sexes of Tonga per year?
Offer a very short reply. 1.71e+04. In the year 2001, what is the difference between the Number of enrolments of both sexes in Argentina and Number of enrolments of both sexes in Luxembourg?
Your answer should be very brief. 4.72e+06. In the year 2001, what is the difference between the Number of enrolments of both sexes in Argentina and Number of enrolments of both sexes in Niger?
Give a very brief answer. 4.10e+06. In the year 2001, what is the difference between the Number of enrolments of both sexes of Argentina and Number of enrolments of both sexes of Tonga?
Make the answer very short. 4.74e+06. In the year 2001, what is the difference between the Number of enrolments of both sexes of Luxembourg and Number of enrolments of both sexes of Niger?
Keep it short and to the point. -6.23e+05. In the year 2001, what is the difference between the Number of enrolments of both sexes of Luxembourg and Number of enrolments of both sexes of Tonga?
Give a very brief answer. 1.62e+04. In the year 2001, what is the difference between the Number of enrolments of both sexes in Niger and Number of enrolments of both sexes in Tonga?
Your answer should be compact. 6.40e+05. In the year 2002, what is the difference between the Number of enrolments of both sexes in Argentina and Number of enrolments of both sexes in Luxembourg?
Provide a short and direct response. 4.74e+06. In the year 2002, what is the difference between the Number of enrolments of both sexes in Argentina and Number of enrolments of both sexes in Niger?
Offer a very short reply. 4.02e+06. In the year 2002, what is the difference between the Number of enrolments of both sexes of Argentina and Number of enrolments of both sexes of Tonga?
Your answer should be very brief. 4.76e+06. In the year 2002, what is the difference between the Number of enrolments of both sexes of Luxembourg and Number of enrolments of both sexes of Niger?
Make the answer very short. -7.27e+05. In the year 2002, what is the difference between the Number of enrolments of both sexes of Luxembourg and Number of enrolments of both sexes of Tonga?
Keep it short and to the point. 1.69e+04. In the year 2002, what is the difference between the Number of enrolments of both sexes of Niger and Number of enrolments of both sexes of Tonga?
Offer a very short reply. 7.44e+05. In the year 2003, what is the difference between the Number of enrolments of both sexes of Argentina and Number of enrolments of both sexes of Luxembourg?
Keep it short and to the point. 4.64e+06. In the year 2003, what is the difference between the Number of enrolments of both sexes of Argentina and Number of enrolments of both sexes of Niger?
Your answer should be very brief. 3.82e+06. In the year 2003, what is the difference between the Number of enrolments of both sexes of Argentina and Number of enrolments of both sexes of Tonga?
Give a very brief answer. 4.66e+06. In the year 2003, what is the difference between the Number of enrolments of both sexes of Luxembourg and Number of enrolments of both sexes of Niger?
Ensure brevity in your answer.  -8.24e+05. In the year 2003, what is the difference between the Number of enrolments of both sexes in Luxembourg and Number of enrolments of both sexes in Tonga?
Ensure brevity in your answer.  1.62e+04. In the year 2003, what is the difference between the Number of enrolments of both sexes in Niger and Number of enrolments of both sexes in Tonga?
Give a very brief answer. 8.40e+05. In the year 2004, what is the difference between the Number of enrolments of both sexes in Argentina and Number of enrolments of both sexes in Luxembourg?
Provide a short and direct response. 4.67e+06. In the year 2004, what is the difference between the Number of enrolments of both sexes in Argentina and Number of enrolments of both sexes in Niger?
Your answer should be very brief. 3.72e+06. In the year 2004, what is the difference between the Number of enrolments of both sexes in Argentina and Number of enrolments of both sexes in Tonga?
Provide a succinct answer. 4.68e+06. In the year 2004, what is the difference between the Number of enrolments of both sexes in Luxembourg and Number of enrolments of both sexes in Niger?
Make the answer very short. -9.45e+05. In the year 2004, what is the difference between the Number of enrolments of both sexes of Luxembourg and Number of enrolments of both sexes of Tonga?
Your answer should be very brief. 1.75e+04. In the year 2004, what is the difference between the Number of enrolments of both sexes in Niger and Number of enrolments of both sexes in Tonga?
Your answer should be compact. 9.63e+05. In the year 2005, what is the difference between the Number of enrolments of both sexes of Argentina and Number of enrolments of both sexes of Luxembourg?
Keep it short and to the point. 4.62e+06. In the year 2005, what is the difference between the Number of enrolments of both sexes of Argentina and Number of enrolments of both sexes of Niger?
Make the answer very short. 3.59e+06. In the year 2005, what is the difference between the Number of enrolments of both sexes in Argentina and Number of enrolments of both sexes in Tonga?
Your answer should be compact. 4.63e+06. In the year 2005, what is the difference between the Number of enrolments of both sexes in Luxembourg and Number of enrolments of both sexes in Niger?
Make the answer very short. -1.03e+06. In the year 2005, what is the difference between the Number of enrolments of both sexes of Luxembourg and Number of enrolments of both sexes of Tonga?
Give a very brief answer. 1.80e+04. In the year 2005, what is the difference between the Number of enrolments of both sexes of Niger and Number of enrolments of both sexes of Tonga?
Your response must be concise. 1.05e+06. In the year 2006, what is the difference between the Number of enrolments of both sexes of Argentina and Number of enrolments of both sexes of Luxembourg?
Offer a very short reply. 4.65e+06. In the year 2006, what is the difference between the Number of enrolments of both sexes in Argentina and Number of enrolments of both sexes in Niger?
Your answer should be compact. 3.56e+06. In the year 2006, what is the difference between the Number of enrolments of both sexes in Argentina and Number of enrolments of both sexes in Tonga?
Offer a terse response. 4.67e+06. In the year 2006, what is the difference between the Number of enrolments of both sexes in Luxembourg and Number of enrolments of both sexes in Niger?
Make the answer very short. -1.09e+06. In the year 2006, what is the difference between the Number of enrolments of both sexes of Luxembourg and Number of enrolments of both sexes of Tonga?
Provide a short and direct response. 1.85e+04. In the year 2006, what is the difference between the Number of enrolments of both sexes of Niger and Number of enrolments of both sexes of Tonga?
Your response must be concise. 1.11e+06. In the year 2007, what is the difference between the Number of enrolments of both sexes in Argentina and Number of enrolments of both sexes in Luxembourg?
Provide a succinct answer. 4.66e+06. In the year 2007, what is the difference between the Number of enrolments of both sexes of Argentina and Number of enrolments of both sexes of Niger?
Offer a very short reply. 3.47e+06. In the year 2007, what is the difference between the Number of enrolments of both sexes of Argentina and Number of enrolments of both sexes of Tonga?
Provide a succinct answer. 4.68e+06. In the year 2007, what is the difference between the Number of enrolments of both sexes in Luxembourg and Number of enrolments of both sexes in Niger?
Offer a terse response. -1.20e+06. In the year 2007, what is the difference between the Number of enrolments of both sexes in Luxembourg and Number of enrolments of both sexes in Tonga?
Give a very brief answer. 1.88e+04. In the year 2007, what is the difference between the Number of enrolments of both sexes of Niger and Number of enrolments of both sexes of Tonga?
Your answer should be very brief. 1.22e+06. In the year 2008, what is the difference between the Number of enrolments of both sexes of Argentina and Number of enrolments of both sexes of Luxembourg?
Ensure brevity in your answer.  4.68e+06. In the year 2008, what is the difference between the Number of enrolments of both sexes in Argentina and Number of enrolments of both sexes in Niger?
Your response must be concise. 3.33e+06. In the year 2008, what is the difference between the Number of enrolments of both sexes in Argentina and Number of enrolments of both sexes in Tonga?
Make the answer very short. 4.70e+06. In the year 2008, what is the difference between the Number of enrolments of both sexes in Luxembourg and Number of enrolments of both sexes in Niger?
Ensure brevity in your answer.  -1.35e+06. In the year 2008, what is the difference between the Number of enrolments of both sexes in Luxembourg and Number of enrolments of both sexes in Tonga?
Provide a succinct answer. 1.90e+04. In the year 2008, what is the difference between the Number of enrolments of both sexes of Niger and Number of enrolments of both sexes of Tonga?
Give a very brief answer. 1.37e+06. What is the ratio of the Number of enrolments of both sexes in Argentina in 2001 to that in 2002?
Offer a very short reply. 1. What is the ratio of the Number of enrolments of both sexes of Luxembourg in 2001 to that in 2002?
Offer a terse response. 0.98. What is the ratio of the Number of enrolments of both sexes of Niger in 2001 to that in 2002?
Give a very brief answer. 0.86. What is the ratio of the Number of enrolments of both sexes of Argentina in 2001 to that in 2003?
Your answer should be very brief. 1.02. What is the ratio of the Number of enrolments of both sexes of Luxembourg in 2001 to that in 2003?
Your answer should be compact. 0.98. What is the ratio of the Number of enrolments of both sexes of Niger in 2001 to that in 2003?
Keep it short and to the point. 0.77. What is the ratio of the Number of enrolments of both sexes of Luxembourg in 2001 to that in 2004?
Ensure brevity in your answer.  0.96. What is the ratio of the Number of enrolments of both sexes in Niger in 2001 to that in 2004?
Make the answer very short. 0.67. What is the ratio of the Number of enrolments of both sexes in Tonga in 2001 to that in 2004?
Your response must be concise. 1. What is the ratio of the Number of enrolments of both sexes in Argentina in 2001 to that in 2005?
Provide a short and direct response. 1.02. What is the ratio of the Number of enrolments of both sexes in Luxembourg in 2001 to that in 2005?
Your response must be concise. 0.95. What is the ratio of the Number of enrolments of both sexes in Niger in 2001 to that in 2005?
Provide a succinct answer. 0.62. What is the ratio of the Number of enrolments of both sexes of Tonga in 2001 to that in 2005?
Ensure brevity in your answer.  1. What is the ratio of the Number of enrolments of both sexes in Argentina in 2001 to that in 2006?
Make the answer very short. 1.02. What is the ratio of the Number of enrolments of both sexes in Luxembourg in 2001 to that in 2006?
Keep it short and to the point. 0.94. What is the ratio of the Number of enrolments of both sexes in Niger in 2001 to that in 2006?
Give a very brief answer. 0.58. What is the ratio of the Number of enrolments of both sexes of Tonga in 2001 to that in 2006?
Make the answer very short. 1.01. What is the ratio of the Number of enrolments of both sexes in Argentina in 2001 to that in 2007?
Your answer should be very brief. 1.01. What is the ratio of the Number of enrolments of both sexes in Luxembourg in 2001 to that in 2007?
Keep it short and to the point. 0.93. What is the ratio of the Number of enrolments of both sexes in Niger in 2001 to that in 2007?
Give a very brief answer. 0.53. What is the ratio of the Number of enrolments of both sexes in Tonga in 2001 to that in 2007?
Provide a short and direct response. 1.01. What is the ratio of the Number of enrolments of both sexes in Argentina in 2001 to that in 2008?
Keep it short and to the point. 1.01. What is the ratio of the Number of enrolments of both sexes in Luxembourg in 2001 to that in 2008?
Offer a terse response. 0.93. What is the ratio of the Number of enrolments of both sexes in Niger in 2001 to that in 2008?
Ensure brevity in your answer.  0.47. What is the ratio of the Number of enrolments of both sexes of Tonga in 2001 to that in 2008?
Offer a very short reply. 1.02. What is the ratio of the Number of enrolments of both sexes in Argentina in 2002 to that in 2003?
Provide a short and direct response. 1.02. What is the ratio of the Number of enrolments of both sexes in Niger in 2002 to that in 2003?
Your response must be concise. 0.89. What is the ratio of the Number of enrolments of both sexes in Tonga in 2002 to that in 2003?
Your response must be concise. 0.96. What is the ratio of the Number of enrolments of both sexes in Argentina in 2002 to that in 2004?
Your answer should be compact. 1.02. What is the ratio of the Number of enrolments of both sexes in Luxembourg in 2002 to that in 2004?
Your response must be concise. 0.98. What is the ratio of the Number of enrolments of both sexes of Niger in 2002 to that in 2004?
Keep it short and to the point. 0.78. What is the ratio of the Number of enrolments of both sexes in Tonga in 2002 to that in 2004?
Your response must be concise. 1. What is the ratio of the Number of enrolments of both sexes of Argentina in 2002 to that in 2005?
Provide a succinct answer. 1.03. What is the ratio of the Number of enrolments of both sexes of Luxembourg in 2002 to that in 2005?
Offer a very short reply. 0.97. What is the ratio of the Number of enrolments of both sexes of Niger in 2002 to that in 2005?
Provide a short and direct response. 0.72. What is the ratio of the Number of enrolments of both sexes of Argentina in 2002 to that in 2006?
Make the answer very short. 1.02. What is the ratio of the Number of enrolments of both sexes in Luxembourg in 2002 to that in 2006?
Provide a short and direct response. 0.96. What is the ratio of the Number of enrolments of both sexes of Niger in 2002 to that in 2006?
Give a very brief answer. 0.68. What is the ratio of the Number of enrolments of both sexes in Tonga in 2002 to that in 2006?
Offer a terse response. 1.01. What is the ratio of the Number of enrolments of both sexes of Argentina in 2002 to that in 2007?
Keep it short and to the point. 1.02. What is the ratio of the Number of enrolments of both sexes in Luxembourg in 2002 to that in 2007?
Offer a terse response. 0.95. What is the ratio of the Number of enrolments of both sexes of Niger in 2002 to that in 2007?
Keep it short and to the point. 0.62. What is the ratio of the Number of enrolments of both sexes of Tonga in 2002 to that in 2007?
Your answer should be very brief. 1.01. What is the ratio of the Number of enrolments of both sexes in Argentina in 2002 to that in 2008?
Give a very brief answer. 1.01. What is the ratio of the Number of enrolments of both sexes of Luxembourg in 2002 to that in 2008?
Keep it short and to the point. 0.95. What is the ratio of the Number of enrolments of both sexes of Niger in 2002 to that in 2008?
Your answer should be very brief. 0.55. What is the ratio of the Number of enrolments of both sexes in Tonga in 2002 to that in 2008?
Offer a terse response. 1.03. What is the ratio of the Number of enrolments of both sexes of Luxembourg in 2003 to that in 2004?
Your answer should be very brief. 0.98. What is the ratio of the Number of enrolments of both sexes in Niger in 2003 to that in 2004?
Your answer should be compact. 0.88. What is the ratio of the Number of enrolments of both sexes in Tonga in 2003 to that in 2004?
Offer a very short reply. 1.05. What is the ratio of the Number of enrolments of both sexes in Argentina in 2003 to that in 2005?
Provide a succinct answer. 1.01. What is the ratio of the Number of enrolments of both sexes in Luxembourg in 2003 to that in 2005?
Ensure brevity in your answer.  0.97. What is the ratio of the Number of enrolments of both sexes of Niger in 2003 to that in 2005?
Your response must be concise. 0.81. What is the ratio of the Number of enrolments of both sexes of Tonga in 2003 to that in 2005?
Provide a succinct answer. 1.05. What is the ratio of the Number of enrolments of both sexes in Argentina in 2003 to that in 2006?
Provide a short and direct response. 1. What is the ratio of the Number of enrolments of both sexes of Luxembourg in 2003 to that in 2006?
Keep it short and to the point. 0.96. What is the ratio of the Number of enrolments of both sexes of Niger in 2003 to that in 2006?
Your answer should be compact. 0.76. What is the ratio of the Number of enrolments of both sexes of Tonga in 2003 to that in 2006?
Give a very brief answer. 1.06. What is the ratio of the Number of enrolments of both sexes of Argentina in 2003 to that in 2007?
Offer a very short reply. 0.99. What is the ratio of the Number of enrolments of both sexes in Luxembourg in 2003 to that in 2007?
Provide a succinct answer. 0.96. What is the ratio of the Number of enrolments of both sexes in Niger in 2003 to that in 2007?
Offer a very short reply. 0.69. What is the ratio of the Number of enrolments of both sexes of Tonga in 2003 to that in 2007?
Your answer should be compact. 1.06. What is the ratio of the Number of enrolments of both sexes of Argentina in 2003 to that in 2008?
Keep it short and to the point. 0.99. What is the ratio of the Number of enrolments of both sexes of Luxembourg in 2003 to that in 2008?
Ensure brevity in your answer.  0.96. What is the ratio of the Number of enrolments of both sexes in Niger in 2003 to that in 2008?
Your response must be concise. 0.62. What is the ratio of the Number of enrolments of both sexes of Tonga in 2003 to that in 2008?
Your response must be concise. 1.07. What is the ratio of the Number of enrolments of both sexes in Argentina in 2004 to that in 2005?
Your answer should be very brief. 1.01. What is the ratio of the Number of enrolments of both sexes of Luxembourg in 2004 to that in 2005?
Your answer should be very brief. 0.99. What is the ratio of the Number of enrolments of both sexes of Niger in 2004 to that in 2005?
Provide a short and direct response. 0.92. What is the ratio of the Number of enrolments of both sexes in Tonga in 2004 to that in 2005?
Your answer should be compact. 1. What is the ratio of the Number of enrolments of both sexes in Luxembourg in 2004 to that in 2006?
Keep it short and to the point. 0.98. What is the ratio of the Number of enrolments of both sexes in Niger in 2004 to that in 2006?
Offer a terse response. 0.87. What is the ratio of the Number of enrolments of both sexes of Tonga in 2004 to that in 2006?
Offer a very short reply. 1.01. What is the ratio of the Number of enrolments of both sexes of Luxembourg in 2004 to that in 2007?
Your response must be concise. 0.97. What is the ratio of the Number of enrolments of both sexes in Niger in 2004 to that in 2007?
Your answer should be very brief. 0.79. What is the ratio of the Number of enrolments of both sexes in Tonga in 2004 to that in 2007?
Your answer should be compact. 1.01. What is the ratio of the Number of enrolments of both sexes in Argentina in 2004 to that in 2008?
Your answer should be very brief. 1. What is the ratio of the Number of enrolments of both sexes in Luxembourg in 2004 to that in 2008?
Your answer should be very brief. 0.97. What is the ratio of the Number of enrolments of both sexes in Niger in 2004 to that in 2008?
Your answer should be very brief. 0.71. What is the ratio of the Number of enrolments of both sexes of Tonga in 2004 to that in 2008?
Your response must be concise. 1.03. What is the ratio of the Number of enrolments of both sexes of Argentina in 2005 to that in 2006?
Ensure brevity in your answer.  0.99. What is the ratio of the Number of enrolments of both sexes in Luxembourg in 2005 to that in 2006?
Your answer should be very brief. 0.99. What is the ratio of the Number of enrolments of both sexes in Niger in 2005 to that in 2006?
Offer a terse response. 0.94. What is the ratio of the Number of enrolments of both sexes of Tonga in 2005 to that in 2006?
Ensure brevity in your answer.  1.01. What is the ratio of the Number of enrolments of both sexes in Argentina in 2005 to that in 2007?
Your response must be concise. 0.99. What is the ratio of the Number of enrolments of both sexes of Luxembourg in 2005 to that in 2007?
Make the answer very short. 0.98. What is the ratio of the Number of enrolments of both sexes in Niger in 2005 to that in 2007?
Offer a terse response. 0.86. What is the ratio of the Number of enrolments of both sexes of Tonga in 2005 to that in 2007?
Provide a succinct answer. 1.01. What is the ratio of the Number of enrolments of both sexes of Argentina in 2005 to that in 2008?
Ensure brevity in your answer.  0.99. What is the ratio of the Number of enrolments of both sexes in Luxembourg in 2005 to that in 2008?
Make the answer very short. 0.98. What is the ratio of the Number of enrolments of both sexes in Niger in 2005 to that in 2008?
Keep it short and to the point. 0.77. What is the ratio of the Number of enrolments of both sexes in Tonga in 2005 to that in 2008?
Offer a very short reply. 1.02. What is the ratio of the Number of enrolments of both sexes in Argentina in 2006 to that in 2007?
Provide a short and direct response. 1. What is the ratio of the Number of enrolments of both sexes in Luxembourg in 2006 to that in 2007?
Offer a very short reply. 0.99. What is the ratio of the Number of enrolments of both sexes of Niger in 2006 to that in 2007?
Provide a short and direct response. 0.91. What is the ratio of the Number of enrolments of both sexes in Tonga in 2006 to that in 2007?
Offer a very short reply. 1. What is the ratio of the Number of enrolments of both sexes in Argentina in 2006 to that in 2008?
Your answer should be very brief. 0.99. What is the ratio of the Number of enrolments of both sexes in Niger in 2006 to that in 2008?
Keep it short and to the point. 0.81. What is the ratio of the Number of enrolments of both sexes in Tonga in 2006 to that in 2008?
Your answer should be compact. 1.02. What is the ratio of the Number of enrolments of both sexes of Niger in 2007 to that in 2008?
Provide a succinct answer. 0.89. What is the ratio of the Number of enrolments of both sexes of Tonga in 2007 to that in 2008?
Offer a very short reply. 1.01. What is the difference between the highest and the second highest Number of enrolments of both sexes of Argentina?
Keep it short and to the point. 1.86e+04. What is the difference between the highest and the second highest Number of enrolments of both sexes of Luxembourg?
Offer a terse response. 38. What is the difference between the highest and the second highest Number of enrolments of both sexes of Niger?
Offer a terse response. 1.54e+05. What is the difference between the highest and the second highest Number of enrolments of both sexes of Tonga?
Provide a succinct answer. 778. What is the difference between the highest and the lowest Number of enrolments of both sexes of Argentina?
Your answer should be very brief. 1.25e+05. What is the difference between the highest and the lowest Number of enrolments of both sexes in Luxembourg?
Provide a succinct answer. 2402. What is the difference between the highest and the lowest Number of enrolments of both sexes in Niger?
Your answer should be compact. 7.33e+05. What is the difference between the highest and the lowest Number of enrolments of both sexes of Tonga?
Give a very brief answer. 1224. 